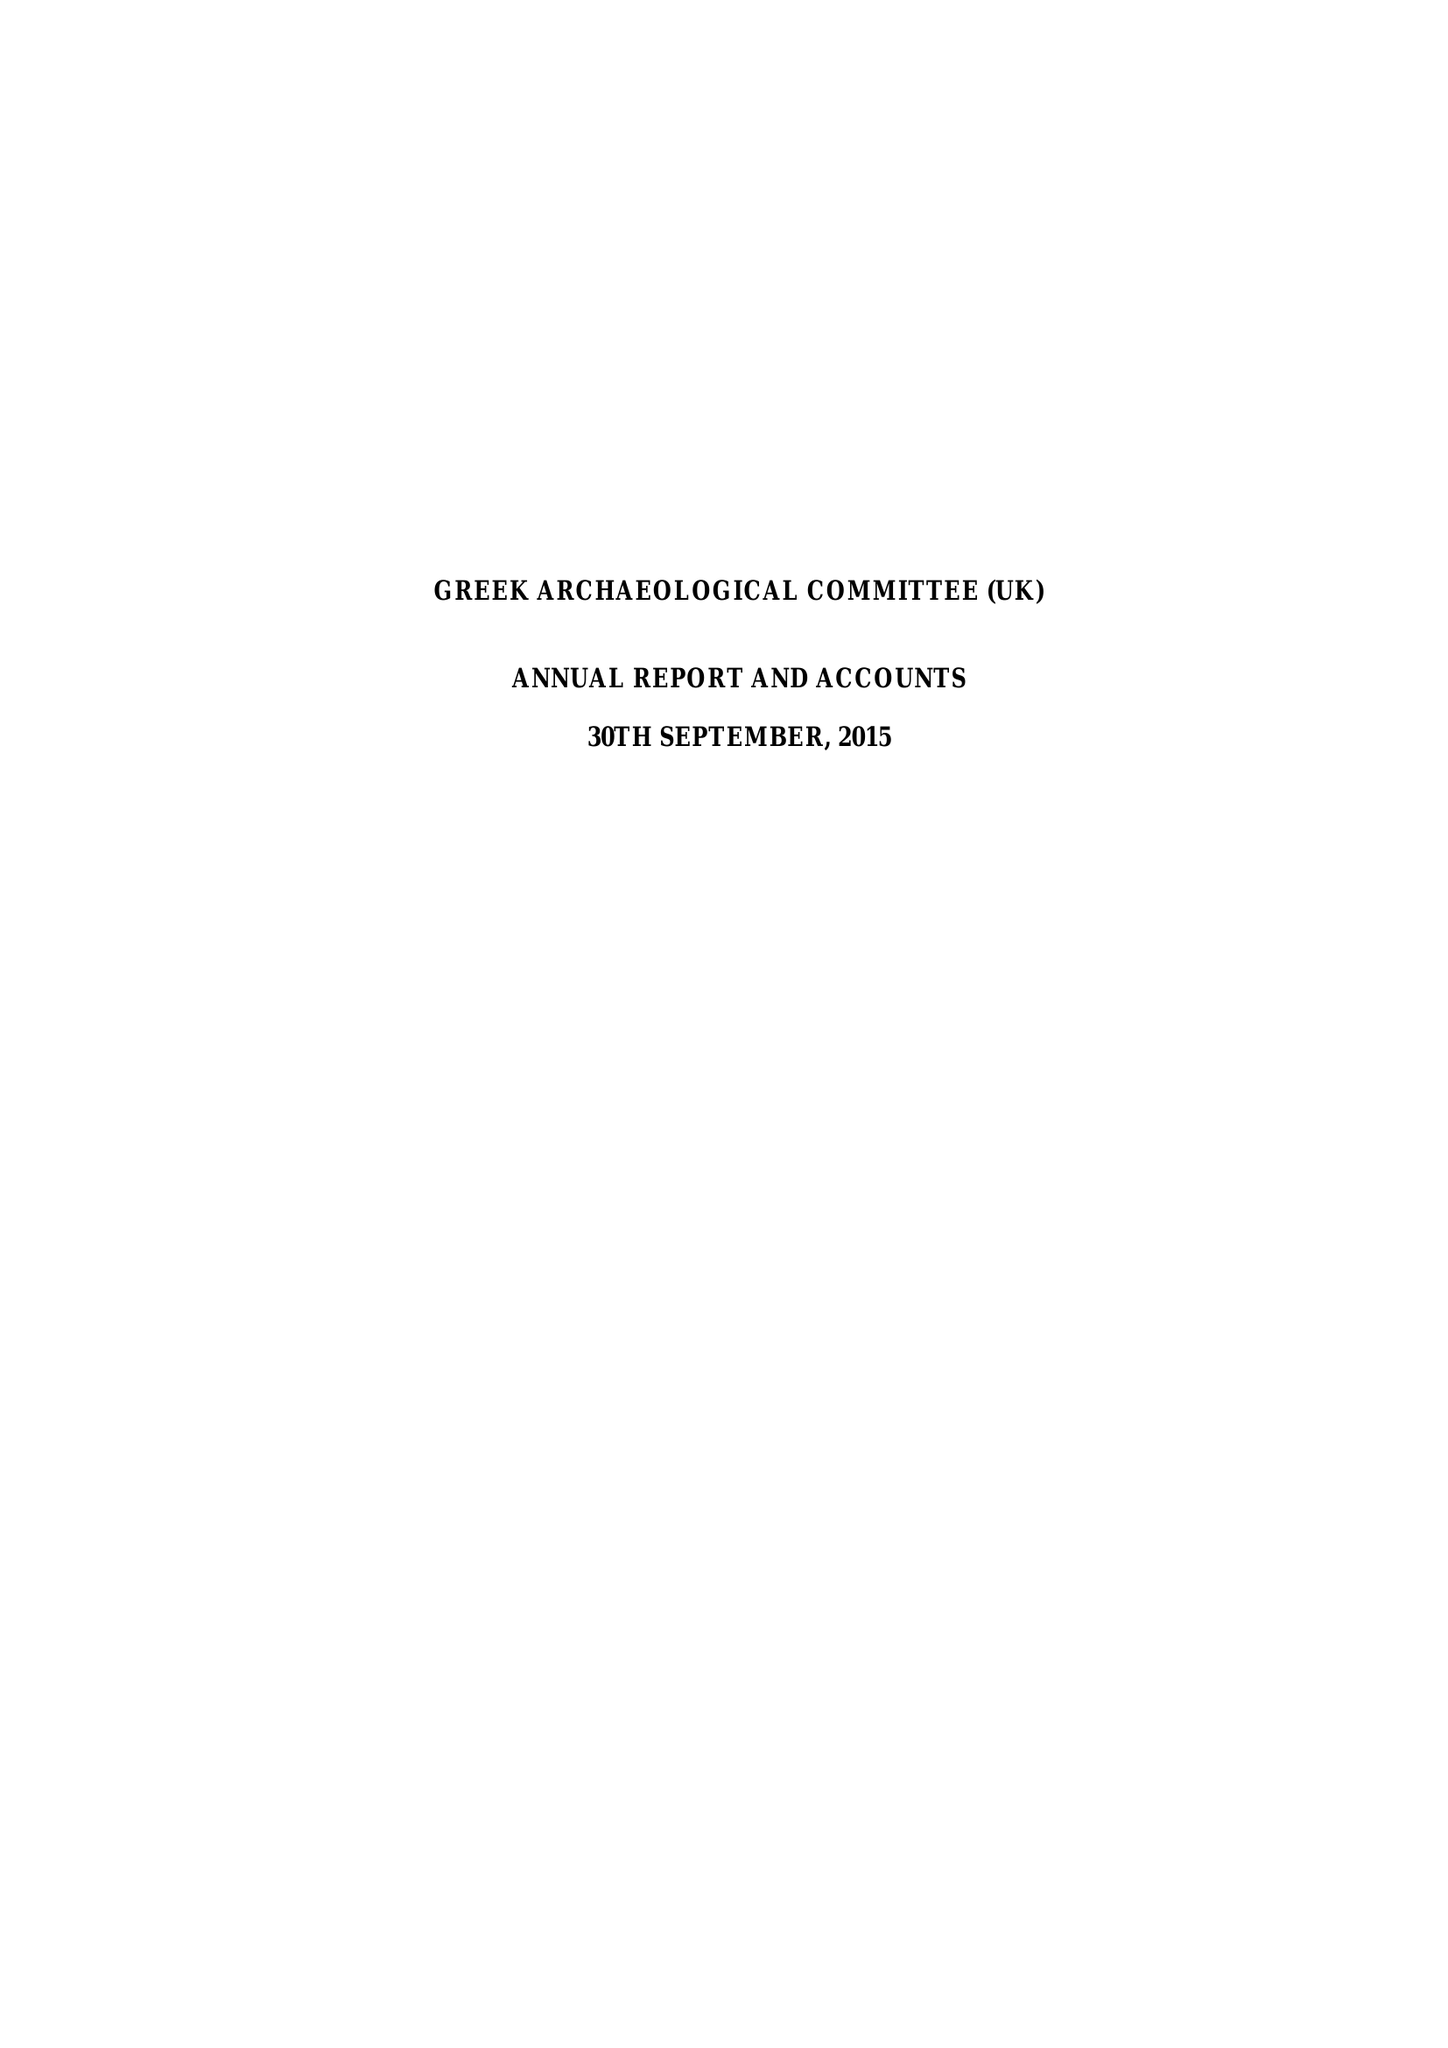What is the value for the charity_name?
Answer the question using a single word or phrase. Greek Archaeological Committee (Uk) 